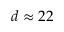Convert formula to latex. <formula><loc_0><loc_0><loc_500><loc_500>d \approx 2 2</formula> 